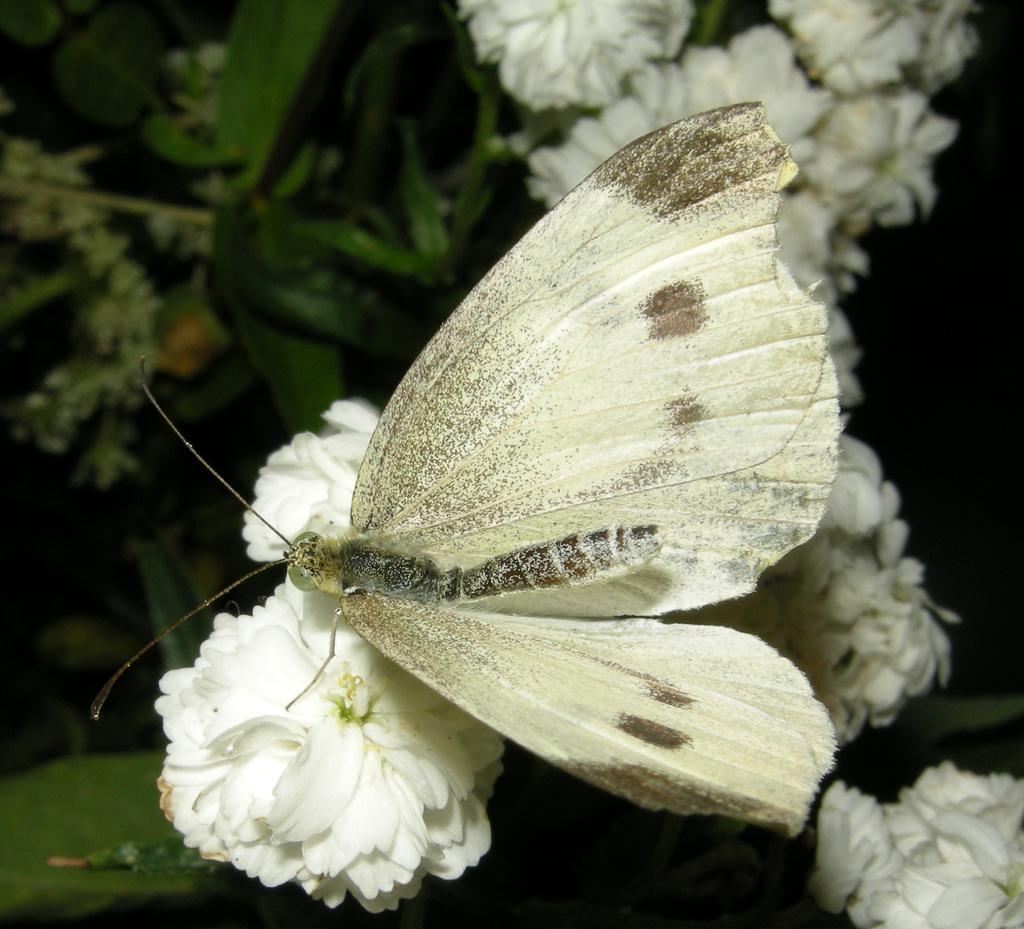Describe this image in one or two sentences. In this image we can see many plants. There are many flowers to the plants. We can see a butterfly sitting on the flower. 